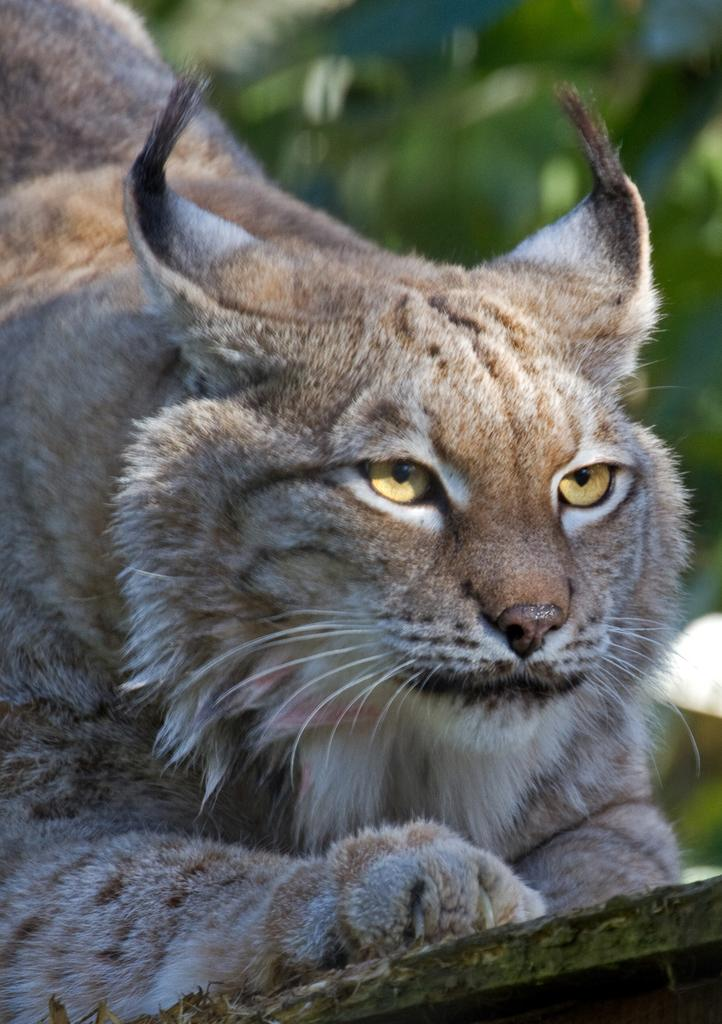What type of animal is present in the image? There is a cat in the image. What can be seen in the background of the image? There are leaves in the background of the image. What color is the wool that the cat is wearing in the image? There is no wool present in the image, nor is the cat wearing any clothing. 